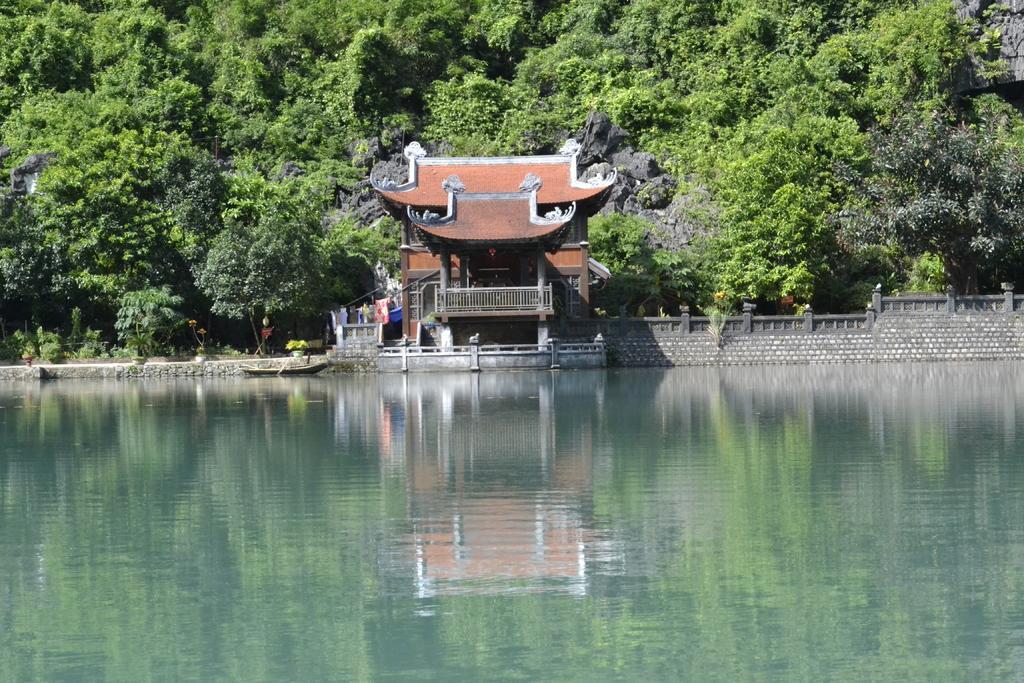In one or two sentences, can you explain what this image depicts? This outdoor picture. On the background of the picture we can see trees. These are the mountains. Here we can see a boat. This is a lake. We can see a building with a different style of arch on the top of it. This is a wall. 